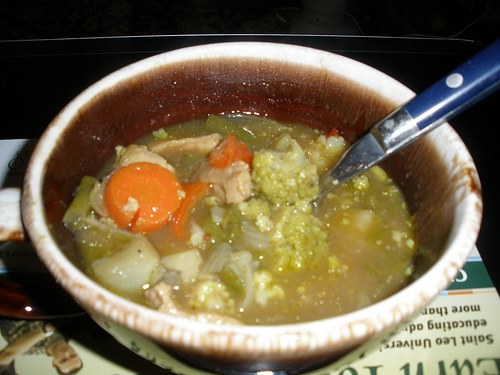What kind of food is to the right of the potato that is on the left side of the image? The food to the right of the potato on the left side of the image is soup. 